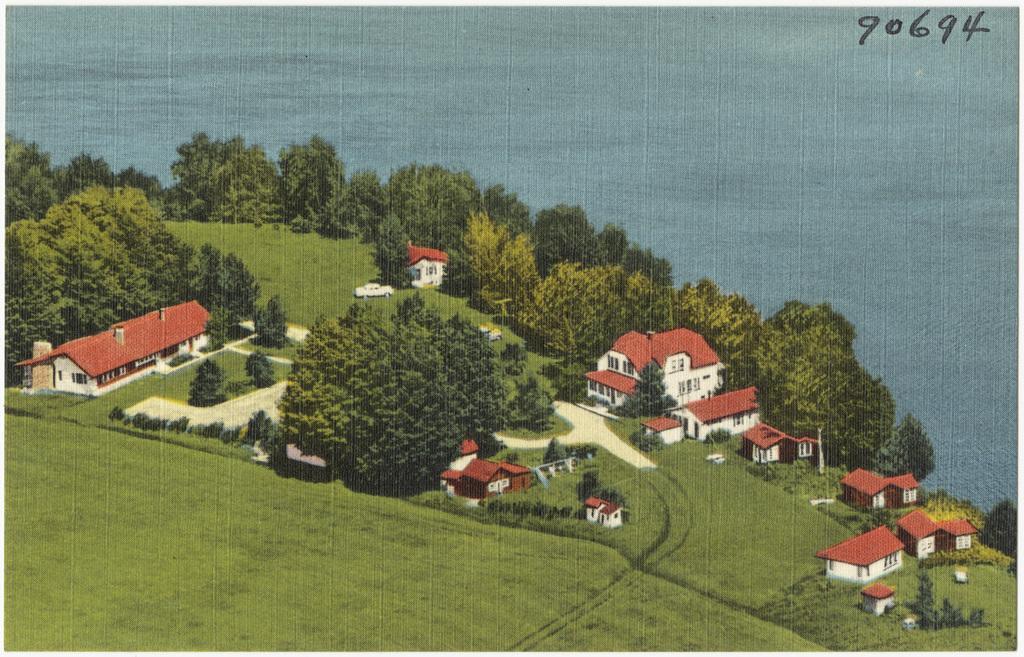Please provide a concise description of this image. In this image, we can see a painting. Here we can see few houses, trees, vehicle, grass. Top of the image, we can see blue color. Right side top corner, we can see some numbers in the image. 